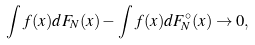<formula> <loc_0><loc_0><loc_500><loc_500>\int f ( x ) d F _ { N } ( x ) - \int f ( x ) d F ^ { \circ } _ { N } ( x ) \to 0 ,</formula> 